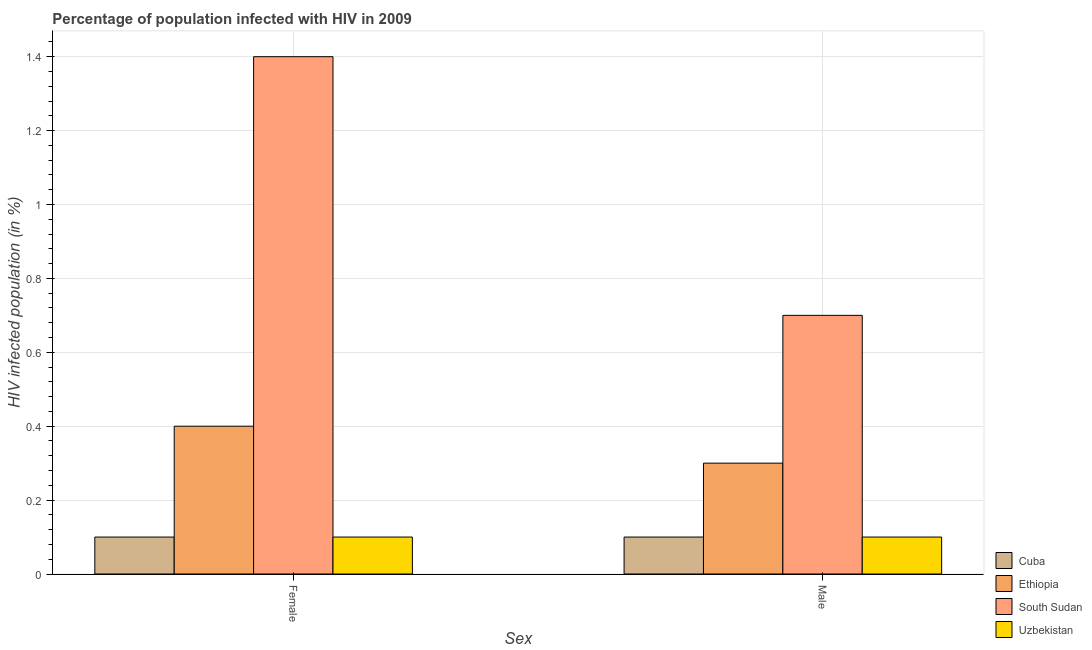How many different coloured bars are there?
Your answer should be very brief. 4. Are the number of bars on each tick of the X-axis equal?
Offer a terse response. Yes. How many bars are there on the 1st tick from the left?
Ensure brevity in your answer.  4. What is the label of the 2nd group of bars from the left?
Make the answer very short. Male. What is the percentage of females who are infected with hiv in Cuba?
Your answer should be very brief. 0.1. Across all countries, what is the maximum percentage of males who are infected with hiv?
Make the answer very short. 0.7. Across all countries, what is the minimum percentage of males who are infected with hiv?
Ensure brevity in your answer.  0.1. In which country was the percentage of males who are infected with hiv maximum?
Ensure brevity in your answer.  South Sudan. In which country was the percentage of females who are infected with hiv minimum?
Your answer should be very brief. Cuba. What is the total percentage of males who are infected with hiv in the graph?
Your answer should be very brief. 1.2. What is the difference between the percentage of females who are infected with hiv in Uzbekistan and that in Ethiopia?
Your answer should be very brief. -0.3. What is the difference between the percentage of females who are infected with hiv in South Sudan and the percentage of males who are infected with hiv in Ethiopia?
Ensure brevity in your answer.  1.1. What is the average percentage of males who are infected with hiv per country?
Provide a succinct answer. 0.3. What is the difference between the percentage of females who are infected with hiv and percentage of males who are infected with hiv in Uzbekistan?
Provide a short and direct response. 0. What is the ratio of the percentage of males who are infected with hiv in Ethiopia to that in South Sudan?
Your response must be concise. 0.43. In how many countries, is the percentage of males who are infected with hiv greater than the average percentage of males who are infected with hiv taken over all countries?
Ensure brevity in your answer.  1. What does the 2nd bar from the left in Male represents?
Keep it short and to the point. Ethiopia. What does the 4th bar from the right in Male represents?
Your answer should be very brief. Cuba. How many bars are there?
Provide a succinct answer. 8. Are all the bars in the graph horizontal?
Offer a very short reply. No. What is the difference between two consecutive major ticks on the Y-axis?
Offer a very short reply. 0.2. Are the values on the major ticks of Y-axis written in scientific E-notation?
Keep it short and to the point. No. Does the graph contain any zero values?
Your answer should be very brief. No. Does the graph contain grids?
Your response must be concise. Yes. How many legend labels are there?
Your answer should be very brief. 4. What is the title of the graph?
Offer a very short reply. Percentage of population infected with HIV in 2009. What is the label or title of the X-axis?
Give a very brief answer. Sex. What is the label or title of the Y-axis?
Your answer should be very brief. HIV infected population (in %). What is the HIV infected population (in %) of Ethiopia in Male?
Give a very brief answer. 0.3. What is the HIV infected population (in %) of South Sudan in Male?
Make the answer very short. 0.7. Across all Sex, what is the maximum HIV infected population (in %) of Cuba?
Provide a short and direct response. 0.1. Across all Sex, what is the maximum HIV infected population (in %) of South Sudan?
Your answer should be compact. 1.4. Across all Sex, what is the maximum HIV infected population (in %) of Uzbekistan?
Offer a very short reply. 0.1. Across all Sex, what is the minimum HIV infected population (in %) in South Sudan?
Keep it short and to the point. 0.7. What is the difference between the HIV infected population (in %) in Cuba in Female and that in Male?
Give a very brief answer. 0. What is the difference between the HIV infected population (in %) in Cuba in Female and the HIV infected population (in %) in Uzbekistan in Male?
Keep it short and to the point. 0. What is the difference between the HIV infected population (in %) of South Sudan in Female and the HIV infected population (in %) of Uzbekistan in Male?
Offer a very short reply. 1.3. What is the average HIV infected population (in %) in Cuba per Sex?
Provide a short and direct response. 0.1. What is the average HIV infected population (in %) of Uzbekistan per Sex?
Your response must be concise. 0.1. What is the difference between the HIV infected population (in %) of Cuba and HIV infected population (in %) of South Sudan in Female?
Provide a short and direct response. -1.3. What is the difference between the HIV infected population (in %) in Ethiopia and HIV infected population (in %) in South Sudan in Female?
Provide a succinct answer. -1. What is the difference between the HIV infected population (in %) in Ethiopia and HIV infected population (in %) in Uzbekistan in Female?
Keep it short and to the point. 0.3. What is the difference between the HIV infected population (in %) in South Sudan and HIV infected population (in %) in Uzbekistan in Female?
Ensure brevity in your answer.  1.3. What is the difference between the HIV infected population (in %) of Cuba and HIV infected population (in %) of Ethiopia in Male?
Provide a succinct answer. -0.2. What is the ratio of the HIV infected population (in %) in Ethiopia in Female to that in Male?
Your answer should be compact. 1.33. What is the ratio of the HIV infected population (in %) in South Sudan in Female to that in Male?
Keep it short and to the point. 2. What is the ratio of the HIV infected population (in %) of Uzbekistan in Female to that in Male?
Your answer should be compact. 1. What is the difference between the highest and the second highest HIV infected population (in %) in Cuba?
Your response must be concise. 0. What is the difference between the highest and the second highest HIV infected population (in %) of South Sudan?
Keep it short and to the point. 0.7. What is the difference between the highest and the lowest HIV infected population (in %) in Cuba?
Make the answer very short. 0. What is the difference between the highest and the lowest HIV infected population (in %) in South Sudan?
Provide a short and direct response. 0.7. 